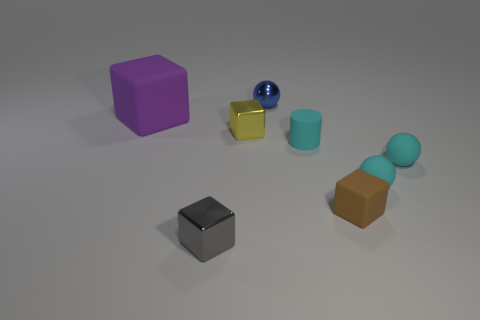Is there anything else that is the same size as the metallic ball?
Your response must be concise. Yes. The matte block that is to the left of the tiny gray metallic cube is what color?
Offer a terse response. Purple. There is a tiny cube that is on the right side of the small rubber object that is to the left of the matte block that is in front of the large purple rubber block; what is its material?
Your response must be concise. Rubber. What is the size of the matte cube in front of the rubber thing on the left side of the blue thing?
Offer a very short reply. Small. What is the color of the other small shiny thing that is the same shape as the small gray shiny object?
Provide a succinct answer. Yellow. How many tiny matte spheres have the same color as the tiny cylinder?
Your answer should be very brief. 2. Do the gray thing and the purple block have the same size?
Provide a short and direct response. No. What is the material of the gray block?
Offer a terse response. Metal. What is the color of the tiny ball that is made of the same material as the yellow thing?
Provide a succinct answer. Blue. Does the small brown cube have the same material as the small ball behind the cylinder?
Offer a terse response. No. 